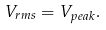<formula> <loc_0><loc_0><loc_500><loc_500>V _ { r m s } = V _ { p e a k } .</formula> 